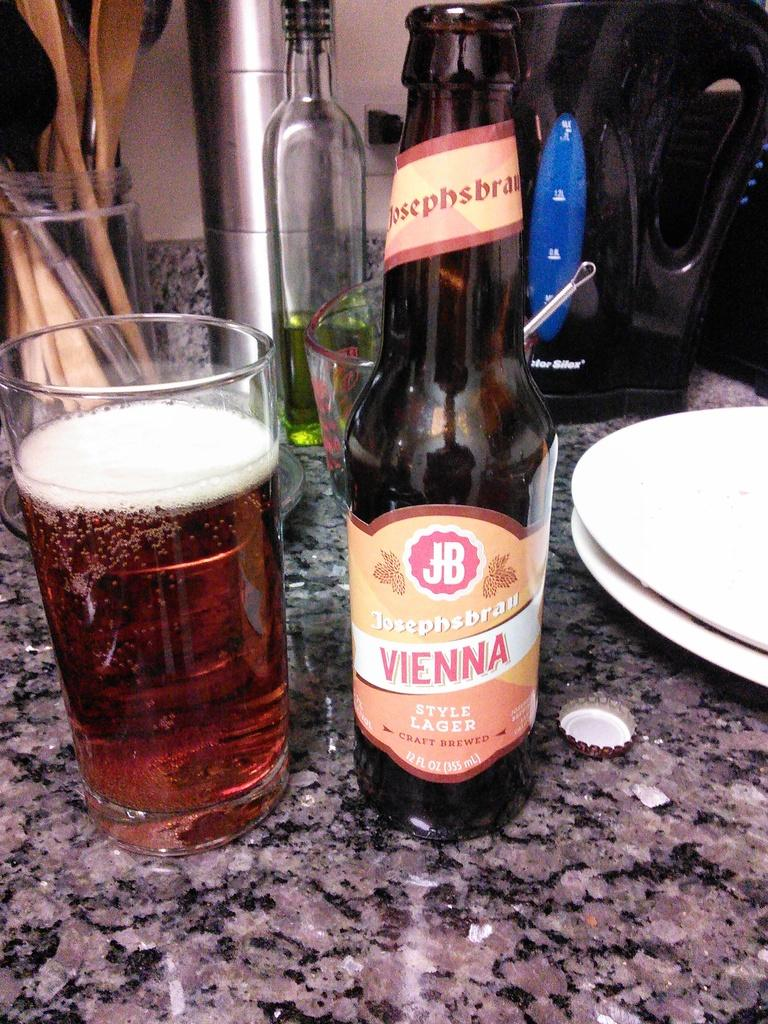Provide a one-sentence caption for the provided image. A beer bottle set on the table with the word vienna on it. 